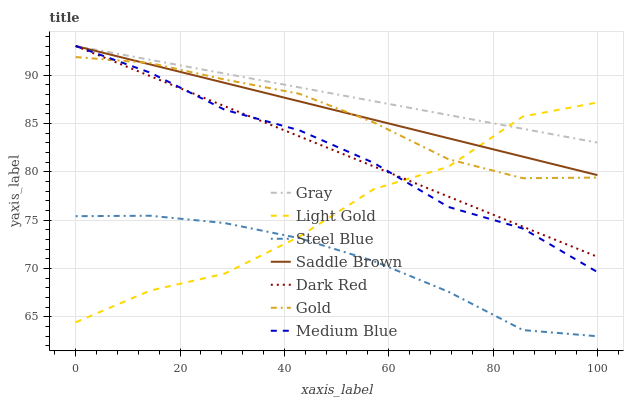Does Steel Blue have the minimum area under the curve?
Answer yes or no. Yes. Does Gray have the maximum area under the curve?
Answer yes or no. Yes. Does Gold have the minimum area under the curve?
Answer yes or no. No. Does Gold have the maximum area under the curve?
Answer yes or no. No. Is Gray the smoothest?
Answer yes or no. Yes. Is Light Gold the roughest?
Answer yes or no. Yes. Is Gold the smoothest?
Answer yes or no. No. Is Gold the roughest?
Answer yes or no. No. Does Steel Blue have the lowest value?
Answer yes or no. Yes. Does Gold have the lowest value?
Answer yes or no. No. Does Saddle Brown have the highest value?
Answer yes or no. Yes. Does Gold have the highest value?
Answer yes or no. No. Is Steel Blue less than Gray?
Answer yes or no. Yes. Is Medium Blue greater than Steel Blue?
Answer yes or no. Yes. Does Medium Blue intersect Gray?
Answer yes or no. Yes. Is Medium Blue less than Gray?
Answer yes or no. No. Is Medium Blue greater than Gray?
Answer yes or no. No. Does Steel Blue intersect Gray?
Answer yes or no. No. 